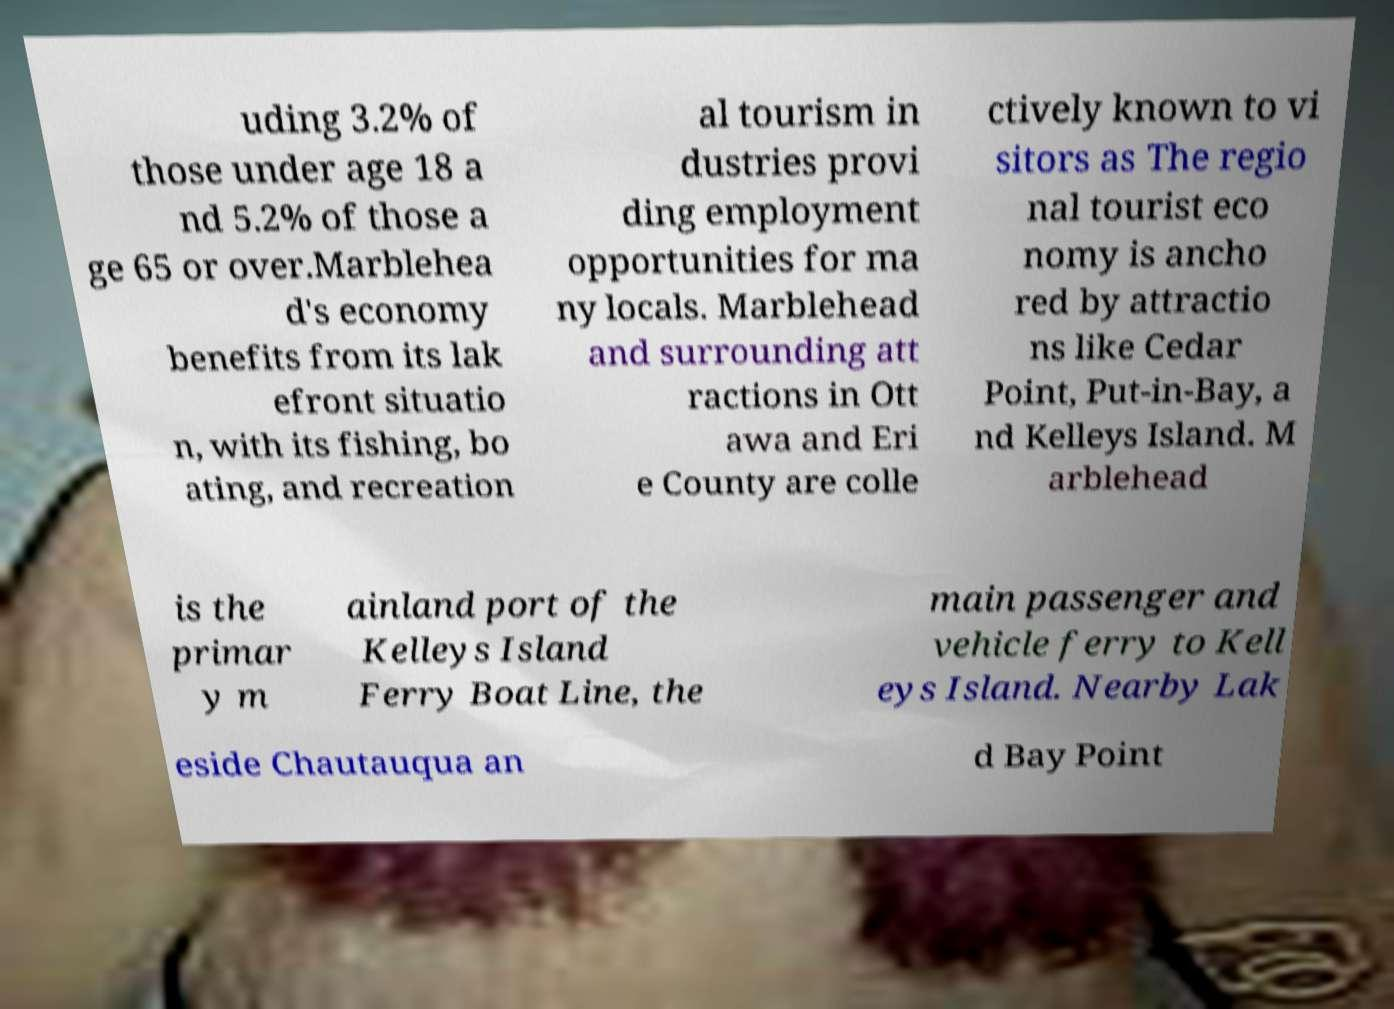There's text embedded in this image that I need extracted. Can you transcribe it verbatim? uding 3.2% of those under age 18 a nd 5.2% of those a ge 65 or over.Marblehea d's economy benefits from its lak efront situatio n, with its fishing, bo ating, and recreation al tourism in dustries provi ding employment opportunities for ma ny locals. Marblehead and surrounding att ractions in Ott awa and Eri e County are colle ctively known to vi sitors as The regio nal tourist eco nomy is ancho red by attractio ns like Cedar Point, Put-in-Bay, a nd Kelleys Island. M arblehead is the primar y m ainland port of the Kelleys Island Ferry Boat Line, the main passenger and vehicle ferry to Kell eys Island. Nearby Lak eside Chautauqua an d Bay Point 